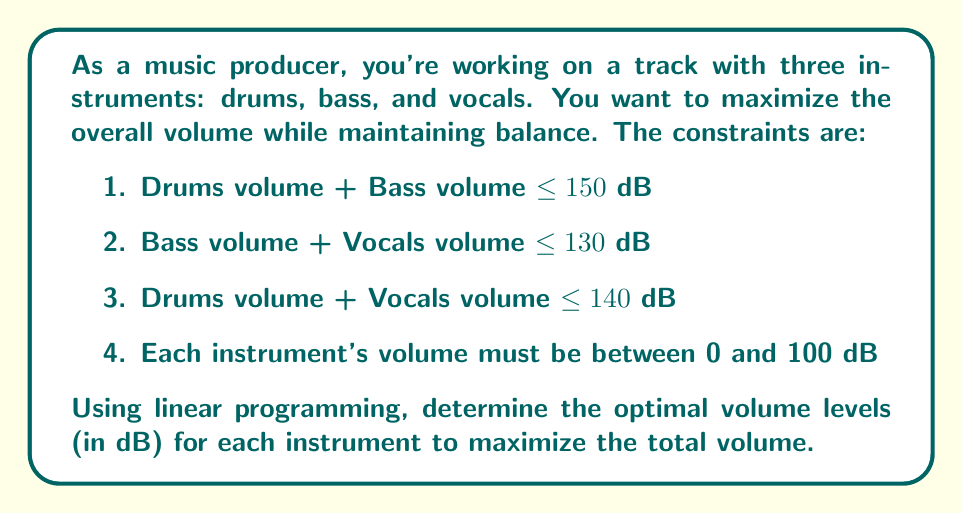Teach me how to tackle this problem. Let's approach this step-by-step using linear programming:

1) Define variables:
   $x$ = Drums volume
   $y$ = Bass volume
   $z$ = Vocals volume

2) Objective function:
   Maximize $f(x,y,z) = x + y + z$

3) Constraints:
   $x + y \leq 150$
   $y + z \leq 130$
   $x + z \leq 140$
   $0 \leq x \leq 100$
   $0 \leq y \leq 100$
   $0 \leq z \leq 100$

4) To solve this, we can use the simplex method or a graphical approach. In this case, we'll use the graphical method.

5) Plot the constraints in 3D space. The feasible region is the intersection of all these constraints.

6) The optimal solution will be at one of the vertices of this feasible region.

7) The vertices that satisfy all constraints are:
   (70, 80, 50), (90, 60, 70), (100, 50, 80)

8) Evaluate the objective function at each vertex:
   $f(70, 80, 50) = 200$
   $f(90, 60, 70) = 220$
   $f(100, 50, 80) = 230$

9) The maximum value is 230, occurring at (100, 50, 80).

Therefore, the optimal volume levels are:
Drums: 100 dB
Bass: 50 dB
Vocals: 80 dB
Answer: Drums: 100 dB, Bass: 50 dB, Vocals: 80 dB 